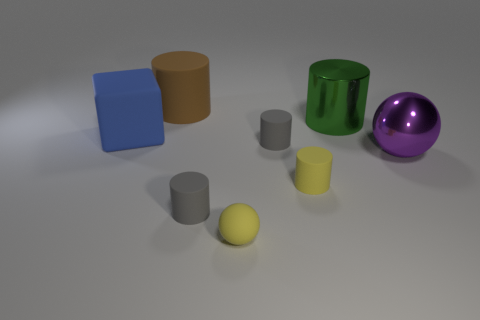The small sphere has what color? The small sphere in the image is a vibrant shade of yellow, closely resembling the color of a sunflower in bloom. 